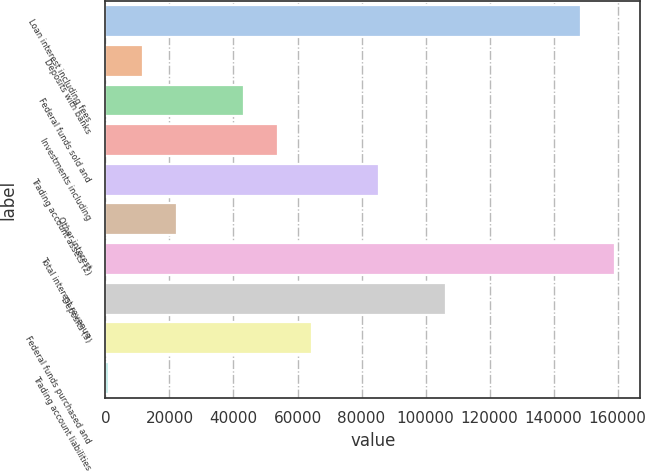Convert chart. <chart><loc_0><loc_0><loc_500><loc_500><bar_chart><fcel>Loan interest including fees<fcel>Deposits with banks<fcel>Federal funds sold and<fcel>Investments including<fcel>Trading account assets (2)<fcel>Other interest<fcel>Total interest revenue<fcel>Deposits (3)<fcel>Federal funds purchased and<fcel>Trading account liabilities<nl><fcel>148596<fcel>11781.2<fcel>43353.8<fcel>53878<fcel>85450.6<fcel>22305.4<fcel>159120<fcel>106499<fcel>64402.2<fcel>1257<nl></chart> 